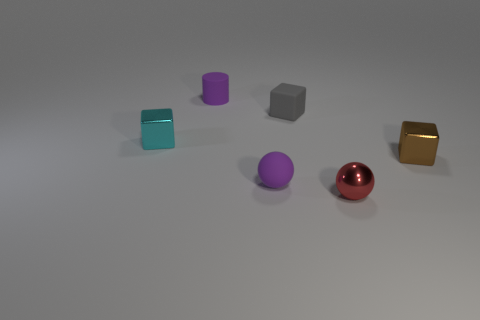There is a metallic sphere; is it the same color as the rubber ball in front of the small cyan object?
Your response must be concise. No. How many tiny rubber balls are behind the small purple object in front of the small cylinder?
Your answer should be very brief. 0. There is a object that is behind the tiny purple ball and on the right side of the gray matte cube; how big is it?
Offer a terse response. Small. Are there any purple shiny cylinders that have the same size as the cyan shiny block?
Ensure brevity in your answer.  No. Is the number of gray things that are behind the gray thing greater than the number of red metal balls left of the purple rubber ball?
Your answer should be compact. No. Is the brown thing made of the same material as the purple thing in front of the gray block?
Make the answer very short. No. There is a cube on the left side of the purple rubber thing behind the cyan block; what number of brown objects are behind it?
Give a very brief answer. 0. There is a tiny gray matte thing; does it have the same shape as the metal thing that is left of the tiny purple cylinder?
Ensure brevity in your answer.  Yes. There is a tiny thing that is both to the left of the purple sphere and in front of the rubber block; what is its color?
Provide a succinct answer. Cyan. What is the cube that is in front of the metal cube behind the tiny shiny block on the right side of the red shiny ball made of?
Provide a succinct answer. Metal. 